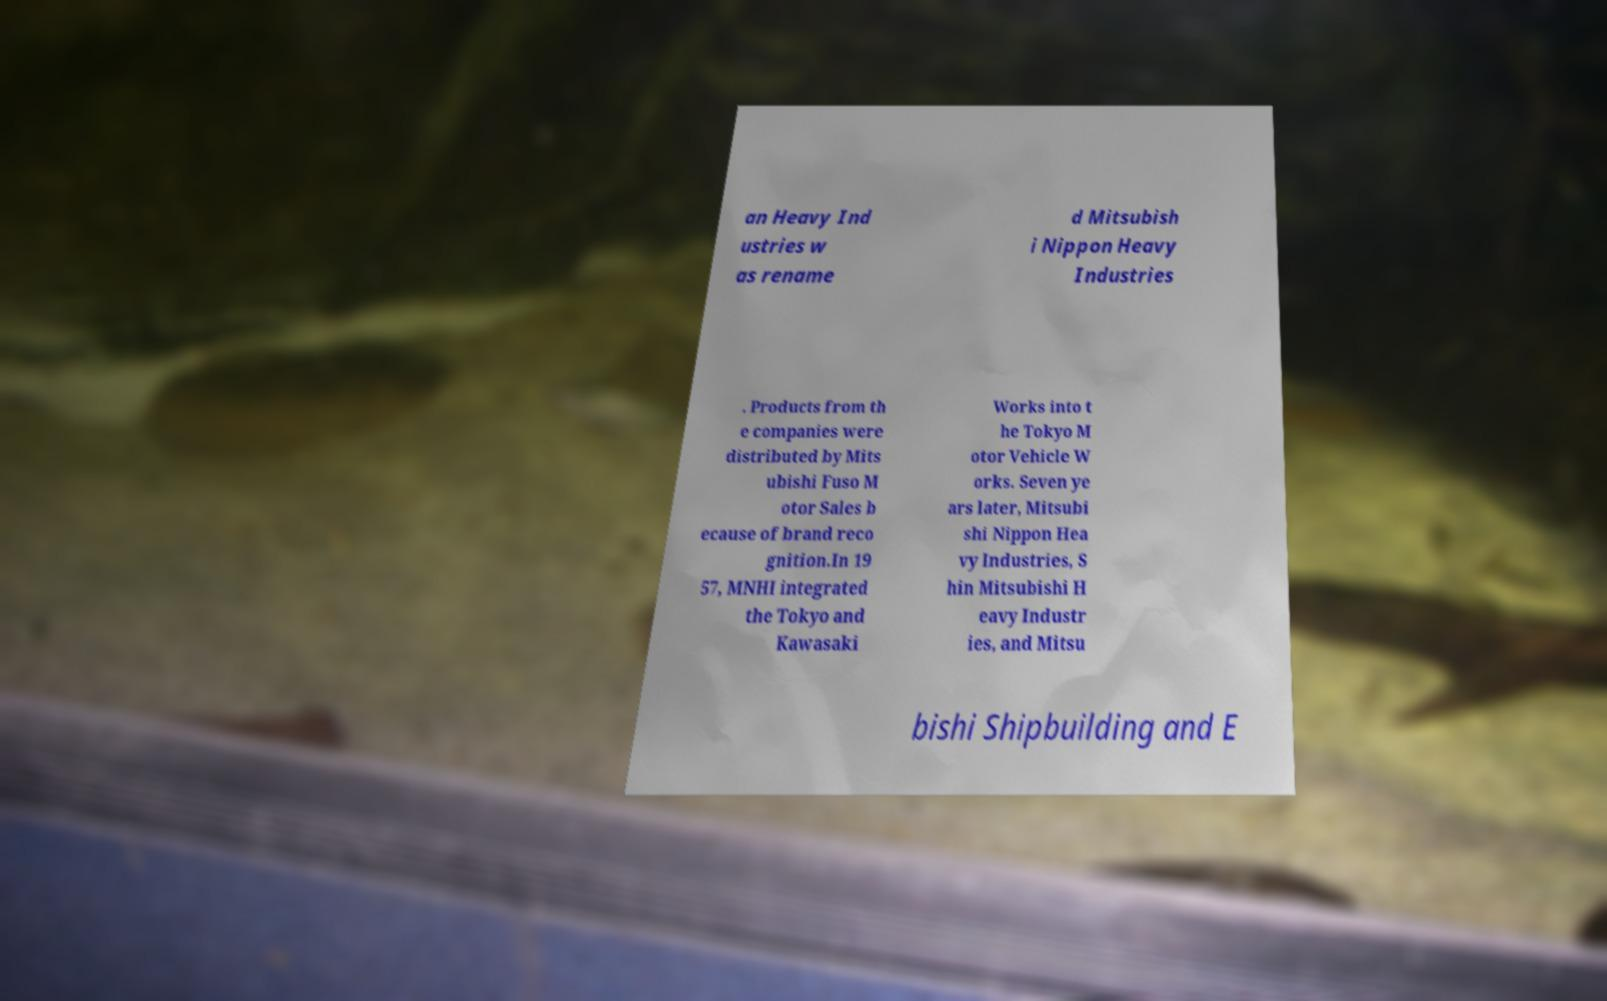What messages or text are displayed in this image? I need them in a readable, typed format. an Heavy Ind ustries w as rename d Mitsubish i Nippon Heavy Industries . Products from th e companies were distributed by Mits ubishi Fuso M otor Sales b ecause of brand reco gnition.In 19 57, MNHI integrated the Tokyo and Kawasaki Works into t he Tokyo M otor Vehicle W orks. Seven ye ars later, Mitsubi shi Nippon Hea vy Industries, S hin Mitsubishi H eavy Industr ies, and Mitsu bishi Shipbuilding and E 